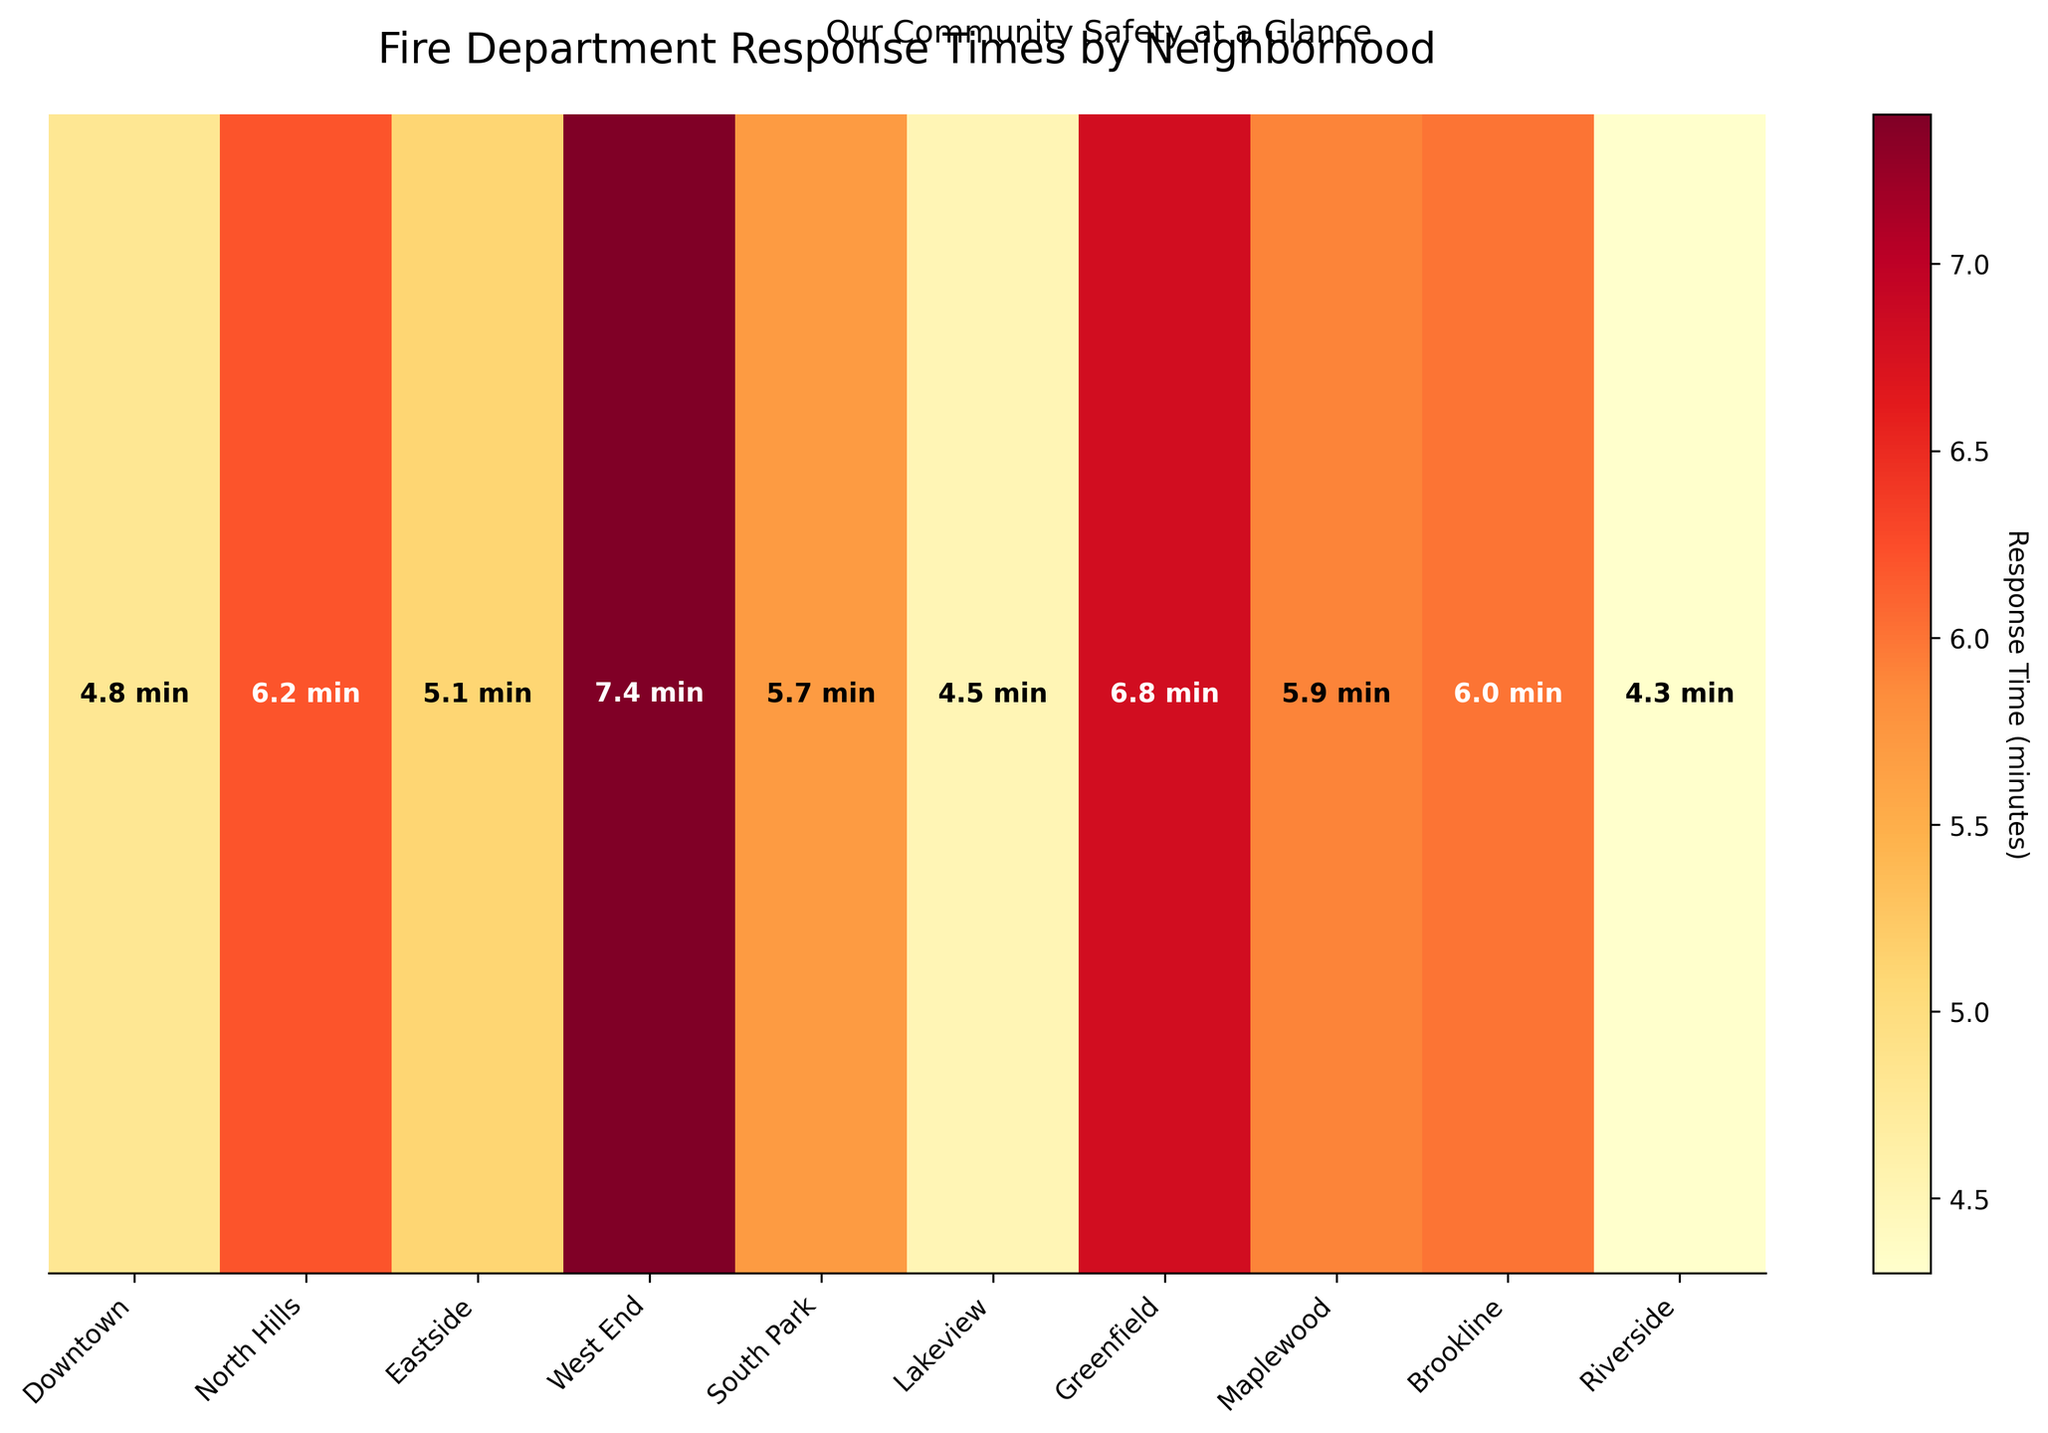What's the title of the heatmap? The title of the heatmap is located at the top center of the image, which provides an overview of the data shown.
Answer: Fire Department Response Times by Neighborhood What does the color bar signify in the heatmap? The color bar typically located to the side of the heatmap explains the color coding used to represent different ranges of response times in minutes.
Answer: Response Time (minutes) Which neighborhood has the fastest response time? By looking at the response times displayed on the heatmap and identifying the lowest value, we can determine the fastest response time. The value "4.3" minutes is the lowest, corresponding to "Riverside".
Answer: Riverside How many neighborhoods have a response time of 6 minutes or greater? Count the neighborhoods with response times labeled as 6 minutes or more. These neighborhoods are North Hills (6.2), West End (7.4), Greenfield (6.8), and Brookline (6.0).
Answer: Four neighborhoods Which neighborhood has the largest response time? Identify the highest response time value among the neighborhoods displayed in the heatmap.
Answer: West End (7.4 minutes) What is the average response time across all neighborhoods? To find the average, sum all the response times (4.8 + 6.2 + 5.1 + 7.4 + 5.7 + 4.5 + 6.8 + 5.9 + 6.0 + 4.3 = 56.7) and divide by the number of neighborhoods (10).
Answer: 5.67 minutes Compare the response times between Eastside and Maplewood. Which is quicker? Eastside has a response time of 5.1 minutes while Maplewood's is 5.9 minutes. Since 5.1 is less than 5.9, Eastside's response time is quicker.
Answer: Eastside What is the difference between the response time of Downtown and South Park? Subtract the response time of South Park from that of Downtown (4.8 - 5.7).
Answer: -0.9 minutes In which neighborhood do you see the darkest color indicating the highest response time? The darkest color represents the highest value in the heatmap, corresponding to the neighborhood with the highest response time.
Answer: West End 